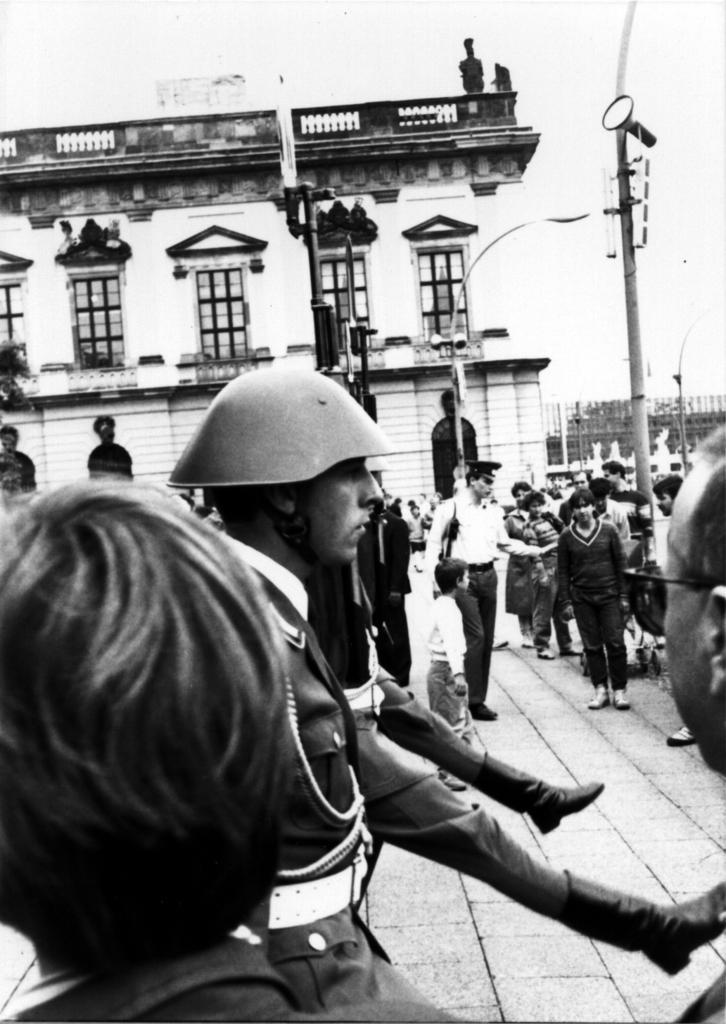Could you give a brief overview of what you see in this image? This is a black and white image. I can see groups of people standing. In the background, I can see a building with the windows and the poles. At the bottom of the image, this is the pathway. 